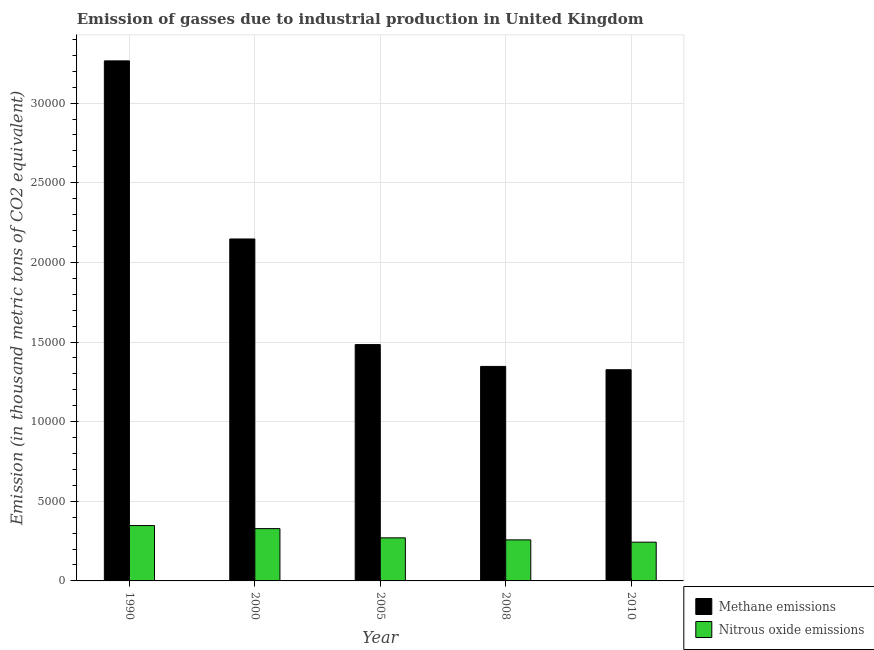How many different coloured bars are there?
Make the answer very short. 2. Are the number of bars per tick equal to the number of legend labels?
Provide a succinct answer. Yes. How many bars are there on the 5th tick from the left?
Your answer should be very brief. 2. What is the label of the 2nd group of bars from the left?
Provide a short and direct response. 2000. In how many cases, is the number of bars for a given year not equal to the number of legend labels?
Your answer should be compact. 0. What is the amount of nitrous oxide emissions in 2005?
Offer a very short reply. 2704.4. Across all years, what is the maximum amount of methane emissions?
Offer a terse response. 3.27e+04. Across all years, what is the minimum amount of nitrous oxide emissions?
Your response must be concise. 2433.2. In which year was the amount of nitrous oxide emissions minimum?
Give a very brief answer. 2010. What is the total amount of nitrous oxide emissions in the graph?
Give a very brief answer. 1.45e+04. What is the difference between the amount of methane emissions in 1990 and that in 2008?
Make the answer very short. 1.92e+04. What is the difference between the amount of methane emissions in 2008 and the amount of nitrous oxide emissions in 2010?
Provide a short and direct response. 208.3. What is the average amount of nitrous oxide emissions per year?
Keep it short and to the point. 2895.04. What is the ratio of the amount of methane emissions in 2005 to that in 2008?
Make the answer very short. 1.1. Is the amount of methane emissions in 1990 less than that in 2010?
Your answer should be compact. No. Is the difference between the amount of nitrous oxide emissions in 2008 and 2010 greater than the difference between the amount of methane emissions in 2008 and 2010?
Your answer should be compact. No. What is the difference between the highest and the second highest amount of methane emissions?
Keep it short and to the point. 1.12e+04. What is the difference between the highest and the lowest amount of methane emissions?
Your response must be concise. 1.94e+04. Is the sum of the amount of methane emissions in 2008 and 2010 greater than the maximum amount of nitrous oxide emissions across all years?
Your answer should be very brief. No. What does the 2nd bar from the left in 2005 represents?
Provide a succinct answer. Nitrous oxide emissions. What does the 1st bar from the right in 2000 represents?
Offer a very short reply. Nitrous oxide emissions. Are all the bars in the graph horizontal?
Offer a terse response. No. Are the values on the major ticks of Y-axis written in scientific E-notation?
Give a very brief answer. No. Does the graph contain any zero values?
Keep it short and to the point. No. How are the legend labels stacked?
Make the answer very short. Vertical. What is the title of the graph?
Ensure brevity in your answer.  Emission of gasses due to industrial production in United Kingdom. What is the label or title of the X-axis?
Your answer should be compact. Year. What is the label or title of the Y-axis?
Your answer should be compact. Emission (in thousand metric tons of CO2 equivalent). What is the Emission (in thousand metric tons of CO2 equivalent) of Methane emissions in 1990?
Your answer should be compact. 3.27e+04. What is the Emission (in thousand metric tons of CO2 equivalent) in Nitrous oxide emissions in 1990?
Offer a terse response. 3476.7. What is the Emission (in thousand metric tons of CO2 equivalent) of Methane emissions in 2000?
Provide a short and direct response. 2.15e+04. What is the Emission (in thousand metric tons of CO2 equivalent) of Nitrous oxide emissions in 2000?
Provide a short and direct response. 3284.4. What is the Emission (in thousand metric tons of CO2 equivalent) of Methane emissions in 2005?
Keep it short and to the point. 1.48e+04. What is the Emission (in thousand metric tons of CO2 equivalent) of Nitrous oxide emissions in 2005?
Offer a very short reply. 2704.4. What is the Emission (in thousand metric tons of CO2 equivalent) in Methane emissions in 2008?
Your answer should be very brief. 1.35e+04. What is the Emission (in thousand metric tons of CO2 equivalent) in Nitrous oxide emissions in 2008?
Your response must be concise. 2576.5. What is the Emission (in thousand metric tons of CO2 equivalent) in Methane emissions in 2010?
Your response must be concise. 1.33e+04. What is the Emission (in thousand metric tons of CO2 equivalent) in Nitrous oxide emissions in 2010?
Give a very brief answer. 2433.2. Across all years, what is the maximum Emission (in thousand metric tons of CO2 equivalent) in Methane emissions?
Your response must be concise. 3.27e+04. Across all years, what is the maximum Emission (in thousand metric tons of CO2 equivalent) in Nitrous oxide emissions?
Make the answer very short. 3476.7. Across all years, what is the minimum Emission (in thousand metric tons of CO2 equivalent) in Methane emissions?
Provide a succinct answer. 1.33e+04. Across all years, what is the minimum Emission (in thousand metric tons of CO2 equivalent) of Nitrous oxide emissions?
Your answer should be compact. 2433.2. What is the total Emission (in thousand metric tons of CO2 equivalent) in Methane emissions in the graph?
Your response must be concise. 9.57e+04. What is the total Emission (in thousand metric tons of CO2 equivalent) in Nitrous oxide emissions in the graph?
Keep it short and to the point. 1.45e+04. What is the difference between the Emission (in thousand metric tons of CO2 equivalent) of Methane emissions in 1990 and that in 2000?
Offer a terse response. 1.12e+04. What is the difference between the Emission (in thousand metric tons of CO2 equivalent) of Nitrous oxide emissions in 1990 and that in 2000?
Make the answer very short. 192.3. What is the difference between the Emission (in thousand metric tons of CO2 equivalent) of Methane emissions in 1990 and that in 2005?
Offer a terse response. 1.78e+04. What is the difference between the Emission (in thousand metric tons of CO2 equivalent) in Nitrous oxide emissions in 1990 and that in 2005?
Provide a succinct answer. 772.3. What is the difference between the Emission (in thousand metric tons of CO2 equivalent) of Methane emissions in 1990 and that in 2008?
Provide a short and direct response. 1.92e+04. What is the difference between the Emission (in thousand metric tons of CO2 equivalent) in Nitrous oxide emissions in 1990 and that in 2008?
Your answer should be very brief. 900.2. What is the difference between the Emission (in thousand metric tons of CO2 equivalent) of Methane emissions in 1990 and that in 2010?
Offer a terse response. 1.94e+04. What is the difference between the Emission (in thousand metric tons of CO2 equivalent) in Nitrous oxide emissions in 1990 and that in 2010?
Your answer should be very brief. 1043.5. What is the difference between the Emission (in thousand metric tons of CO2 equivalent) of Methane emissions in 2000 and that in 2005?
Offer a terse response. 6631. What is the difference between the Emission (in thousand metric tons of CO2 equivalent) in Nitrous oxide emissions in 2000 and that in 2005?
Provide a succinct answer. 580. What is the difference between the Emission (in thousand metric tons of CO2 equivalent) of Methane emissions in 2000 and that in 2008?
Give a very brief answer. 8001.7. What is the difference between the Emission (in thousand metric tons of CO2 equivalent) in Nitrous oxide emissions in 2000 and that in 2008?
Offer a terse response. 707.9. What is the difference between the Emission (in thousand metric tons of CO2 equivalent) in Methane emissions in 2000 and that in 2010?
Provide a succinct answer. 8210. What is the difference between the Emission (in thousand metric tons of CO2 equivalent) in Nitrous oxide emissions in 2000 and that in 2010?
Offer a terse response. 851.2. What is the difference between the Emission (in thousand metric tons of CO2 equivalent) in Methane emissions in 2005 and that in 2008?
Your answer should be compact. 1370.7. What is the difference between the Emission (in thousand metric tons of CO2 equivalent) of Nitrous oxide emissions in 2005 and that in 2008?
Your answer should be compact. 127.9. What is the difference between the Emission (in thousand metric tons of CO2 equivalent) in Methane emissions in 2005 and that in 2010?
Provide a short and direct response. 1579. What is the difference between the Emission (in thousand metric tons of CO2 equivalent) in Nitrous oxide emissions in 2005 and that in 2010?
Give a very brief answer. 271.2. What is the difference between the Emission (in thousand metric tons of CO2 equivalent) in Methane emissions in 2008 and that in 2010?
Your answer should be compact. 208.3. What is the difference between the Emission (in thousand metric tons of CO2 equivalent) in Nitrous oxide emissions in 2008 and that in 2010?
Keep it short and to the point. 143.3. What is the difference between the Emission (in thousand metric tons of CO2 equivalent) in Methane emissions in 1990 and the Emission (in thousand metric tons of CO2 equivalent) in Nitrous oxide emissions in 2000?
Your answer should be very brief. 2.94e+04. What is the difference between the Emission (in thousand metric tons of CO2 equivalent) of Methane emissions in 1990 and the Emission (in thousand metric tons of CO2 equivalent) of Nitrous oxide emissions in 2005?
Make the answer very short. 2.99e+04. What is the difference between the Emission (in thousand metric tons of CO2 equivalent) of Methane emissions in 1990 and the Emission (in thousand metric tons of CO2 equivalent) of Nitrous oxide emissions in 2008?
Provide a short and direct response. 3.01e+04. What is the difference between the Emission (in thousand metric tons of CO2 equivalent) in Methane emissions in 1990 and the Emission (in thousand metric tons of CO2 equivalent) in Nitrous oxide emissions in 2010?
Keep it short and to the point. 3.02e+04. What is the difference between the Emission (in thousand metric tons of CO2 equivalent) of Methane emissions in 2000 and the Emission (in thousand metric tons of CO2 equivalent) of Nitrous oxide emissions in 2005?
Give a very brief answer. 1.88e+04. What is the difference between the Emission (in thousand metric tons of CO2 equivalent) of Methane emissions in 2000 and the Emission (in thousand metric tons of CO2 equivalent) of Nitrous oxide emissions in 2008?
Make the answer very short. 1.89e+04. What is the difference between the Emission (in thousand metric tons of CO2 equivalent) of Methane emissions in 2000 and the Emission (in thousand metric tons of CO2 equivalent) of Nitrous oxide emissions in 2010?
Give a very brief answer. 1.90e+04. What is the difference between the Emission (in thousand metric tons of CO2 equivalent) of Methane emissions in 2005 and the Emission (in thousand metric tons of CO2 equivalent) of Nitrous oxide emissions in 2008?
Offer a terse response. 1.23e+04. What is the difference between the Emission (in thousand metric tons of CO2 equivalent) in Methane emissions in 2005 and the Emission (in thousand metric tons of CO2 equivalent) in Nitrous oxide emissions in 2010?
Your answer should be very brief. 1.24e+04. What is the difference between the Emission (in thousand metric tons of CO2 equivalent) of Methane emissions in 2008 and the Emission (in thousand metric tons of CO2 equivalent) of Nitrous oxide emissions in 2010?
Your answer should be compact. 1.10e+04. What is the average Emission (in thousand metric tons of CO2 equivalent) of Methane emissions per year?
Give a very brief answer. 1.91e+04. What is the average Emission (in thousand metric tons of CO2 equivalent) of Nitrous oxide emissions per year?
Offer a very short reply. 2895.04. In the year 1990, what is the difference between the Emission (in thousand metric tons of CO2 equivalent) in Methane emissions and Emission (in thousand metric tons of CO2 equivalent) in Nitrous oxide emissions?
Your answer should be very brief. 2.92e+04. In the year 2000, what is the difference between the Emission (in thousand metric tons of CO2 equivalent) in Methane emissions and Emission (in thousand metric tons of CO2 equivalent) in Nitrous oxide emissions?
Provide a succinct answer. 1.82e+04. In the year 2005, what is the difference between the Emission (in thousand metric tons of CO2 equivalent) in Methane emissions and Emission (in thousand metric tons of CO2 equivalent) in Nitrous oxide emissions?
Give a very brief answer. 1.21e+04. In the year 2008, what is the difference between the Emission (in thousand metric tons of CO2 equivalent) in Methane emissions and Emission (in thousand metric tons of CO2 equivalent) in Nitrous oxide emissions?
Offer a terse response. 1.09e+04. In the year 2010, what is the difference between the Emission (in thousand metric tons of CO2 equivalent) of Methane emissions and Emission (in thousand metric tons of CO2 equivalent) of Nitrous oxide emissions?
Provide a succinct answer. 1.08e+04. What is the ratio of the Emission (in thousand metric tons of CO2 equivalent) in Methane emissions in 1990 to that in 2000?
Provide a short and direct response. 1.52. What is the ratio of the Emission (in thousand metric tons of CO2 equivalent) of Nitrous oxide emissions in 1990 to that in 2000?
Your answer should be very brief. 1.06. What is the ratio of the Emission (in thousand metric tons of CO2 equivalent) in Methane emissions in 1990 to that in 2005?
Provide a short and direct response. 2.2. What is the ratio of the Emission (in thousand metric tons of CO2 equivalent) in Nitrous oxide emissions in 1990 to that in 2005?
Keep it short and to the point. 1.29. What is the ratio of the Emission (in thousand metric tons of CO2 equivalent) of Methane emissions in 1990 to that in 2008?
Offer a terse response. 2.42. What is the ratio of the Emission (in thousand metric tons of CO2 equivalent) of Nitrous oxide emissions in 1990 to that in 2008?
Make the answer very short. 1.35. What is the ratio of the Emission (in thousand metric tons of CO2 equivalent) in Methane emissions in 1990 to that in 2010?
Provide a short and direct response. 2.46. What is the ratio of the Emission (in thousand metric tons of CO2 equivalent) of Nitrous oxide emissions in 1990 to that in 2010?
Make the answer very short. 1.43. What is the ratio of the Emission (in thousand metric tons of CO2 equivalent) of Methane emissions in 2000 to that in 2005?
Offer a terse response. 1.45. What is the ratio of the Emission (in thousand metric tons of CO2 equivalent) in Nitrous oxide emissions in 2000 to that in 2005?
Your answer should be very brief. 1.21. What is the ratio of the Emission (in thousand metric tons of CO2 equivalent) of Methane emissions in 2000 to that in 2008?
Make the answer very short. 1.59. What is the ratio of the Emission (in thousand metric tons of CO2 equivalent) in Nitrous oxide emissions in 2000 to that in 2008?
Keep it short and to the point. 1.27. What is the ratio of the Emission (in thousand metric tons of CO2 equivalent) in Methane emissions in 2000 to that in 2010?
Offer a terse response. 1.62. What is the ratio of the Emission (in thousand metric tons of CO2 equivalent) of Nitrous oxide emissions in 2000 to that in 2010?
Your answer should be very brief. 1.35. What is the ratio of the Emission (in thousand metric tons of CO2 equivalent) of Methane emissions in 2005 to that in 2008?
Offer a terse response. 1.1. What is the ratio of the Emission (in thousand metric tons of CO2 equivalent) in Nitrous oxide emissions in 2005 to that in 2008?
Ensure brevity in your answer.  1.05. What is the ratio of the Emission (in thousand metric tons of CO2 equivalent) of Methane emissions in 2005 to that in 2010?
Ensure brevity in your answer.  1.12. What is the ratio of the Emission (in thousand metric tons of CO2 equivalent) of Nitrous oxide emissions in 2005 to that in 2010?
Ensure brevity in your answer.  1.11. What is the ratio of the Emission (in thousand metric tons of CO2 equivalent) of Methane emissions in 2008 to that in 2010?
Keep it short and to the point. 1.02. What is the ratio of the Emission (in thousand metric tons of CO2 equivalent) in Nitrous oxide emissions in 2008 to that in 2010?
Provide a succinct answer. 1.06. What is the difference between the highest and the second highest Emission (in thousand metric tons of CO2 equivalent) of Methane emissions?
Your answer should be very brief. 1.12e+04. What is the difference between the highest and the second highest Emission (in thousand metric tons of CO2 equivalent) in Nitrous oxide emissions?
Offer a very short reply. 192.3. What is the difference between the highest and the lowest Emission (in thousand metric tons of CO2 equivalent) of Methane emissions?
Provide a succinct answer. 1.94e+04. What is the difference between the highest and the lowest Emission (in thousand metric tons of CO2 equivalent) in Nitrous oxide emissions?
Provide a succinct answer. 1043.5. 